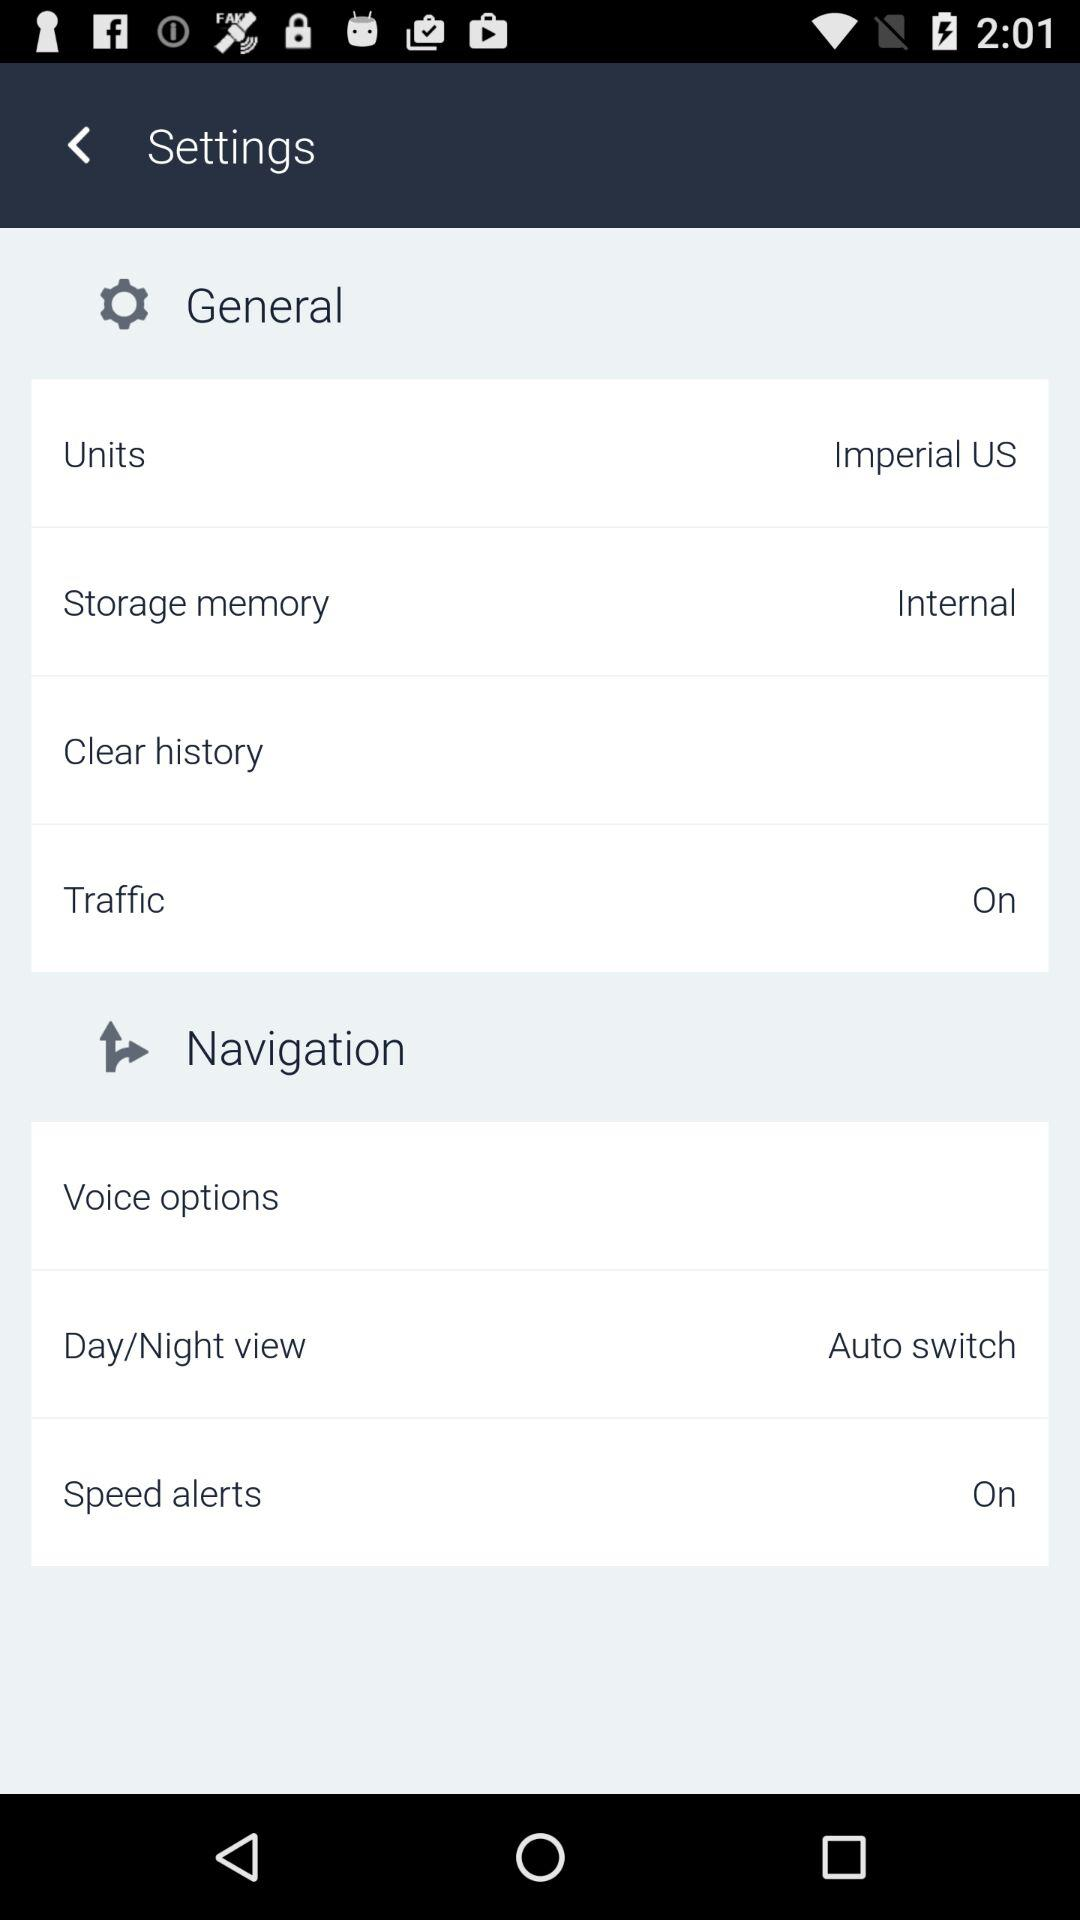What is the mentioned unit? The mentioned unit is the imperial US. 